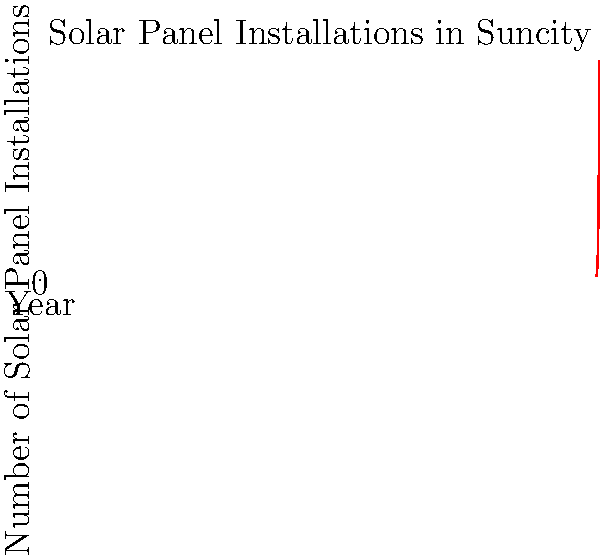The graph shows the growth of solar panel installations in Suncity from 2010 to 2020. What type of growth does this curve most closely represent, and what might this suggest about the city's renewable energy policies and public reception? To analyze the growth curve of solar panel installations in Suncity:

1. Observe the shape: The curve is not linear but shows an increasing rate of growth over time.

2. Identify growth type: This pattern resembles exponential growth, where the rate of increase becomes larger over time.

3. Calculate growth rate:
   - 2010 to 2015: Increased from 100 to 759 (659% over 5 years)
   - 2015 to 2020: Increased from 759 to 5762 (659% over 5 years)
   The similar percentage increase over shorter periods indicates accelerating growth.

4. Interpret the curve:
   - Exponential growth suggests a positive feedback loop in adoption.
   - Initial slow growth followed by rapid acceleration is typical of successful technology adoption.

5. Implications for policy and reception:
   - Effective incentives or regulations likely drove initial adoption.
   - Positive experiences of early adopters may have encouraged others.
   - Decreasing costs and improving technology could have made solar more accessible over time.
   - Public awareness and acceptance of renewable energy likely increased.

6. Conclusion: The exponential growth curve suggests highly successful renewable energy policies and positive public reception in Suncity.
Answer: Exponential growth, indicating successful policies and positive public reception. 